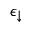<formula> <loc_0><loc_0><loc_500><loc_500>\epsilon _ { \downarrow }</formula> 